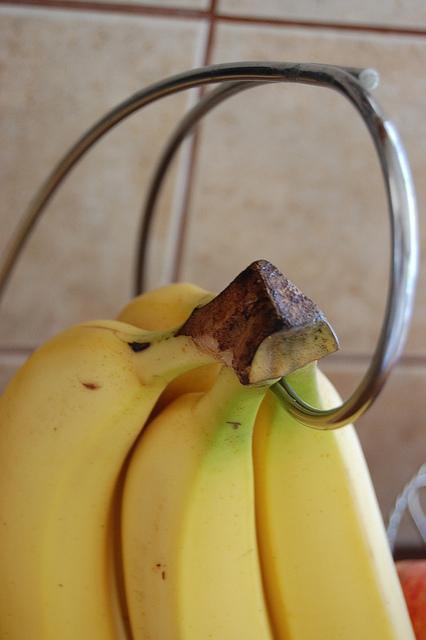How many bananas are in the picture?
Give a very brief answer. 4. 